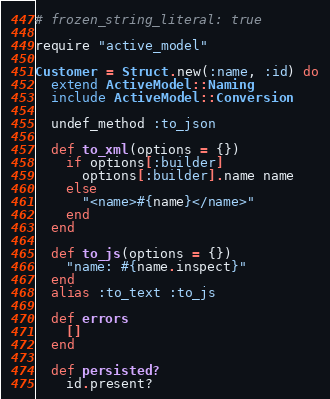Convert code to text. <code><loc_0><loc_0><loc_500><loc_500><_Ruby_># frozen_string_literal: true

require "active_model"

Customer = Struct.new(:name, :id) do
  extend ActiveModel::Naming
  include ActiveModel::Conversion

  undef_method :to_json

  def to_xml(options = {})
    if options[:builder]
      options[:builder].name name
    else
      "<name>#{name}</name>"
    end
  end

  def to_js(options = {})
    "name: #{name.inspect}"
  end
  alias :to_text :to_js

  def errors
    []
  end

  def persisted?
    id.present?</code> 